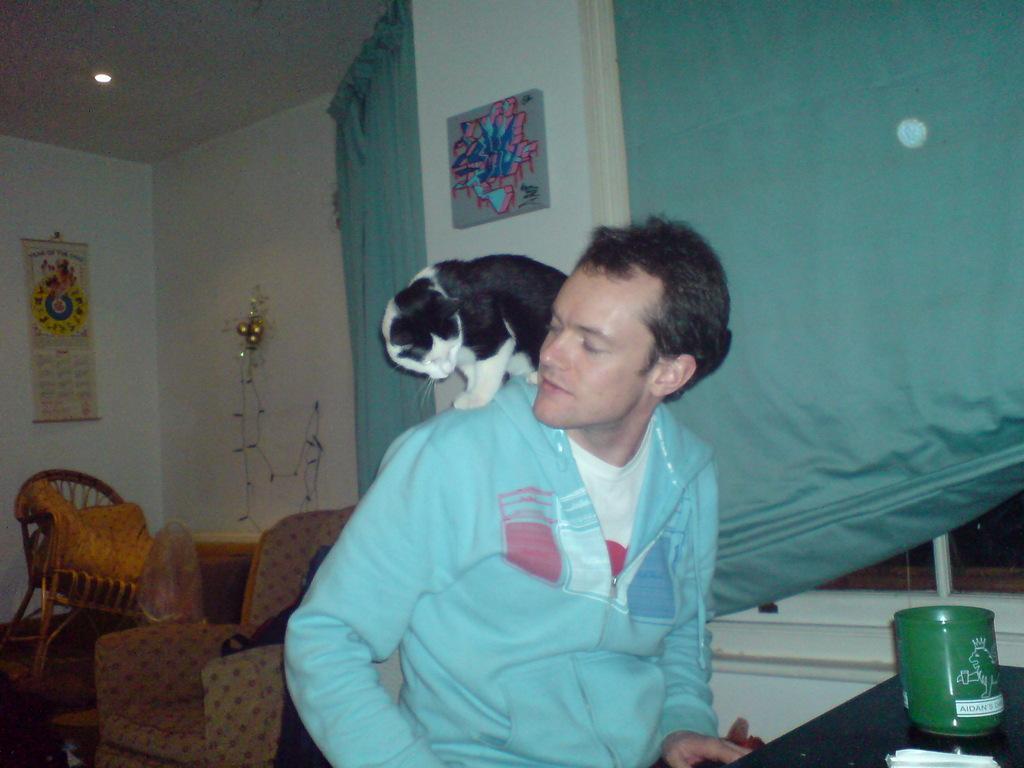Please provide a concise description of this image. In this image in the center there is one person who is sitting and there is one cat on him, on the right side there is one table. On the table there is one box, and on the left side there are some chairs. And in the background there is a wall, on the wall there is calendar, lights, photo frame and some curtains. 